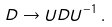Convert formula to latex. <formula><loc_0><loc_0><loc_500><loc_500>D \to U D U ^ { - 1 } \, .</formula> 